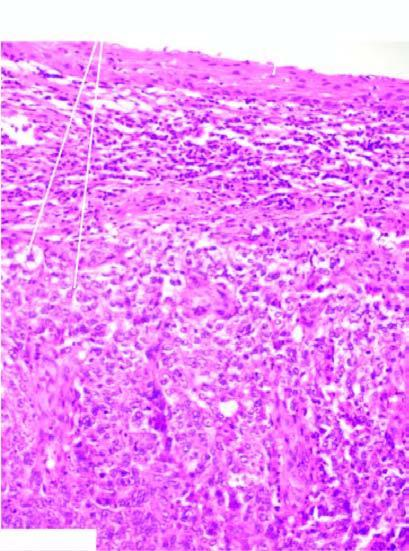what is the tumour composed of?
Answer the question using a single word or phrase. Undifferentiated anaplastic cells arranged in nests 